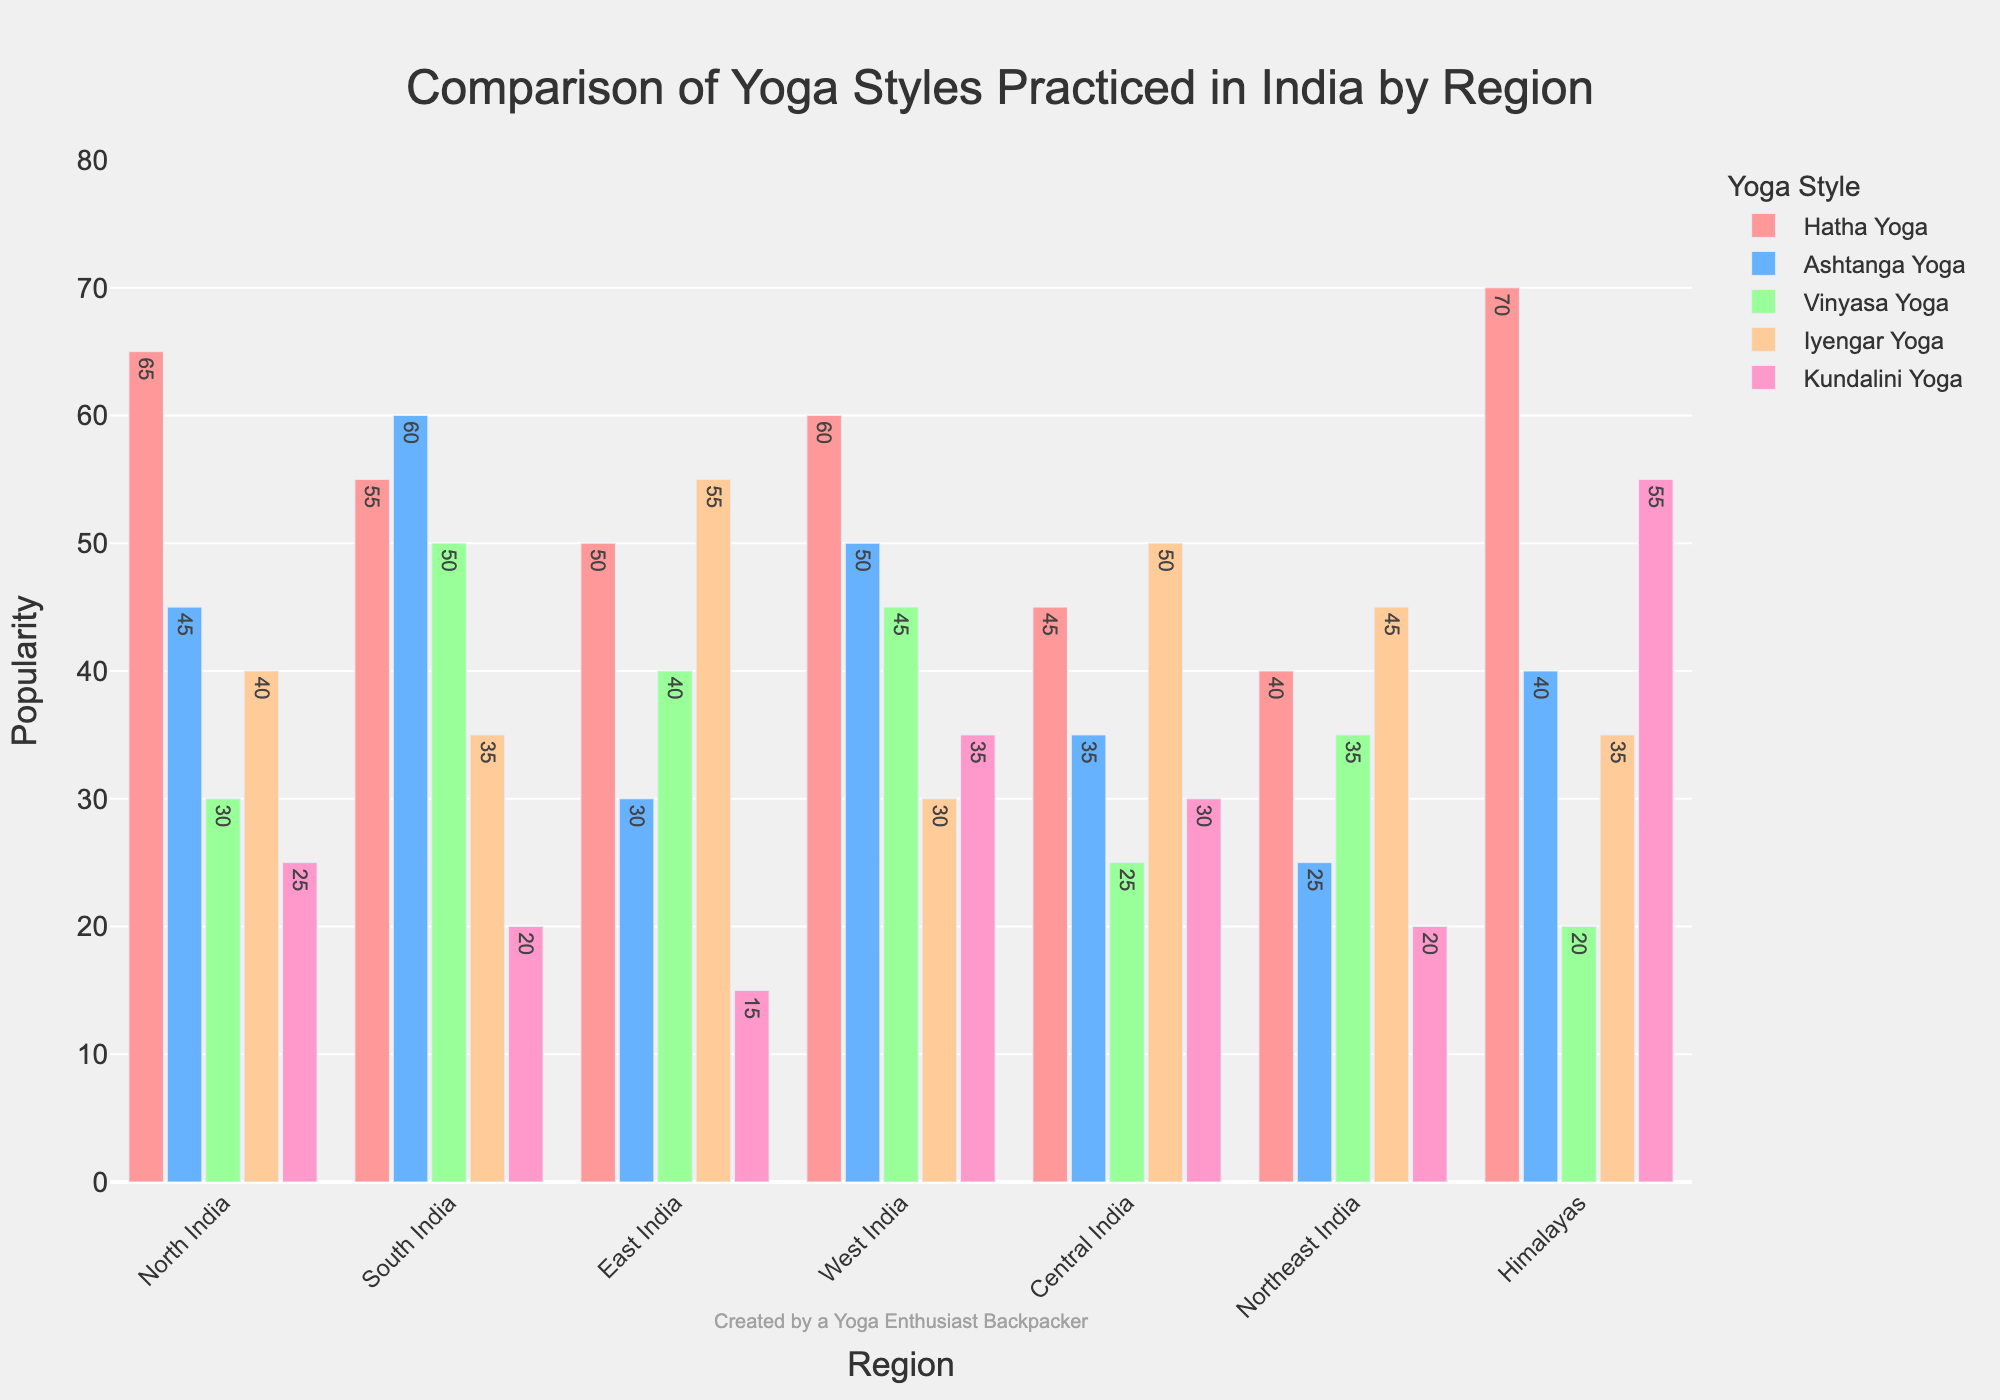What is the most popular yoga style in North India? By observing the height of the bars for North India, the Hatha Yoga bar is the tallest.
Answer: Hatha Yoga Which region practices Kundalini Yoga the least? By comparing the height of the Kundalini Yoga bars for all regions, East India has the shortest bar.
Answer: East India What is the total popularity of Vinyasa Yoga in all regions combined? Summing up the Vinyasa Yoga values for all regions (30 + 50 + 40 + 45 + 25 + 35 + 20) gives 245.
Answer: 245 In which region is the difference between the popularity of Hatha Yoga and Ashtanga Yoga the greatest? Calculating the differences (North India: 65-45=20, South India: 55-60=-5, East India: 50-30=20, West India: 60-50=10, Central India: 45-35=10, Northeast India: 40-25=15, Himalayas: 70-40=30), the Himalayas have the largest difference.
Answer: Himalayas Which yoga style is the second most popular in the Himalayas? By observing the heights of the bars for the Himalayas, Kundalini Yoga is the second tallest bar after Hatha Yoga.
Answer: Kundalini Yoga How many regions have Iyengar Yoga as the most popular yoga style? Checking each region, only East India practices Iyengar Yoga the most.
Answer: 1 What is the average popularity of Ashtanga Yoga in South and West India? Adding the popularity values for South India (60) and West India (50) gives 110. Dividing by 2 gives an average of 55.
Answer: 55 Comparing North India and South India, which region has a higher total popularity for all yoga styles combined? Summing the values by region (North India: 65+45+30+40+25=205, South India: 55+60+50+35+20=220), South India has a higher total.
Answer: South India Between North and Central India, which region has a greater difference between the highest and lowest popularities of yoga styles? For North India (highest: 65, lowest: 25, difference: 40) and Central India (highest: 50, lowest: 25, difference: 25), North India has a greater difference.
Answer: North India What color represents Iyengar Yoga in the plot? By visually identifying the color associated with Iyengar Yoga, it is shown in a light orange color on the chart.
Answer: Light orange 